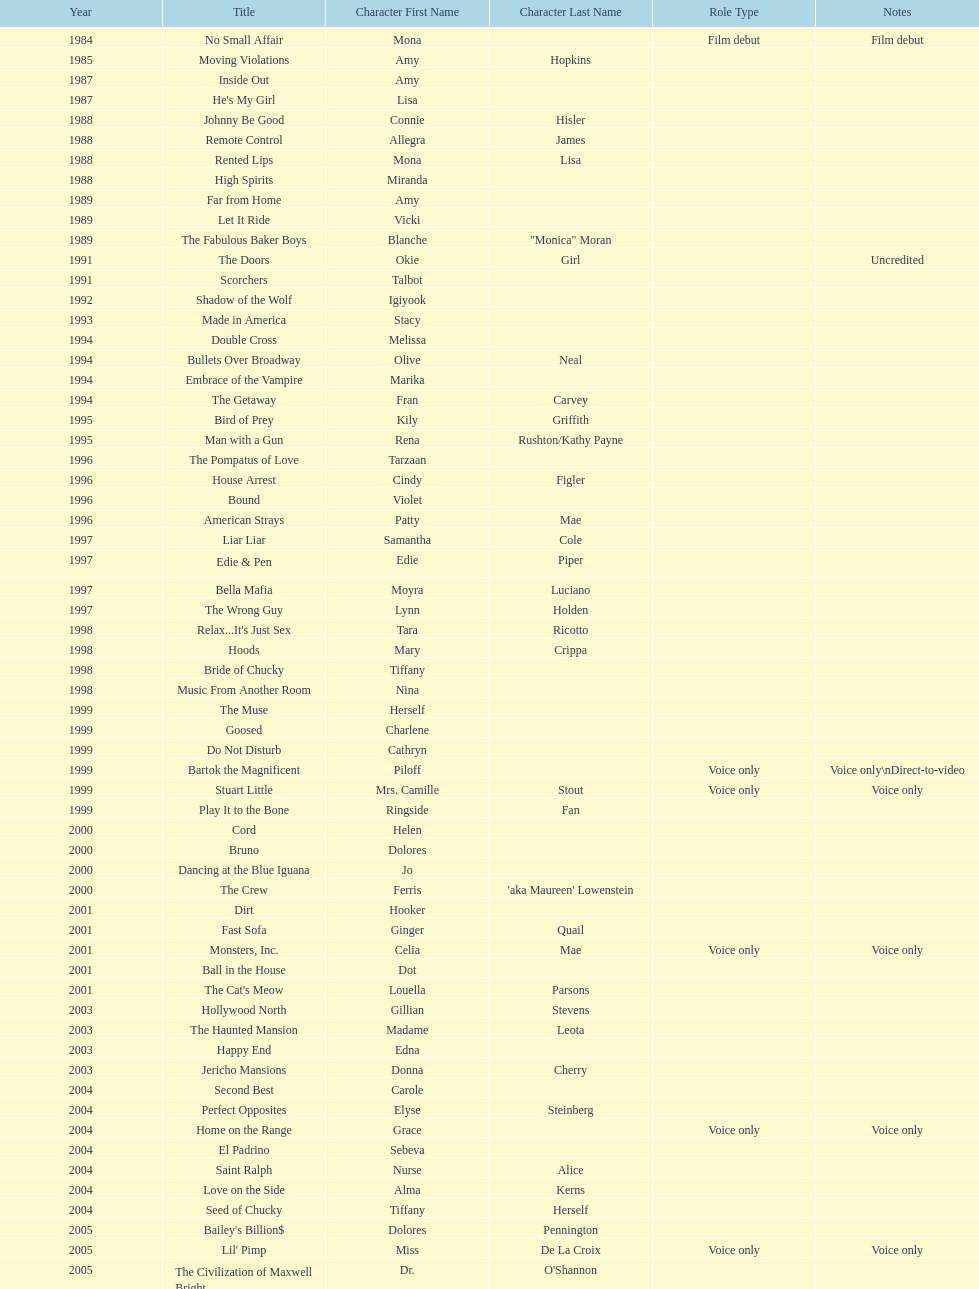How many rolls did jennifer tilly play in the 1980s? 11. 